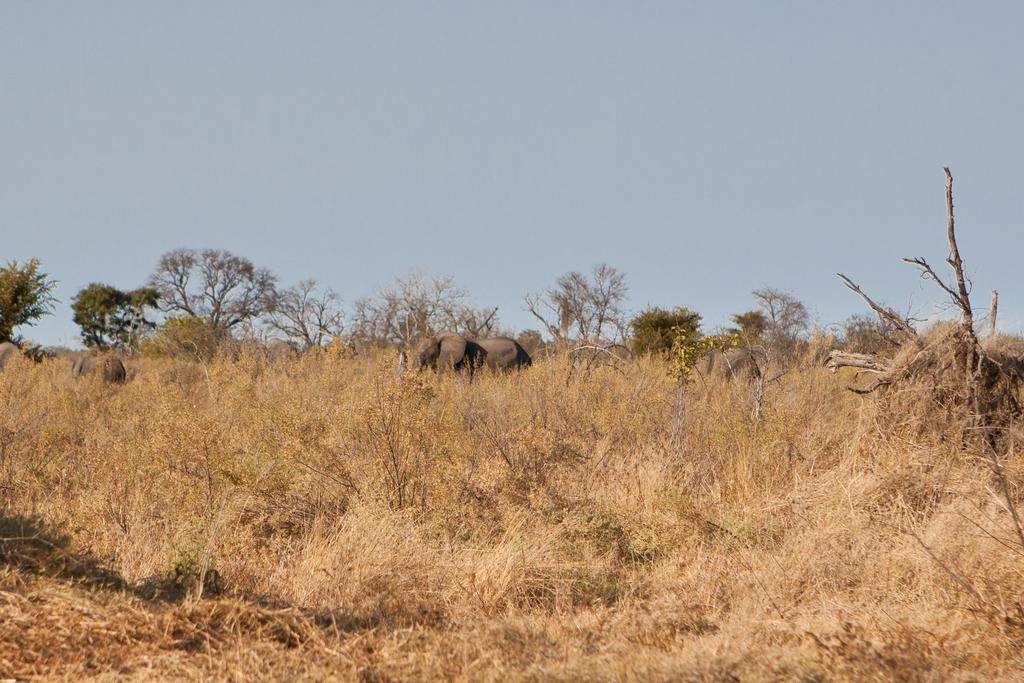What animals can be seen in the image? There are elephants in the image. What type of vegetation is present in the image? There are trees and dried plants in the image. What can be seen in the background of the image? The sky is visible in the background of the image. What type of zinc is being used as bait for the elephants in the image? There is no zinc or bait present in the image; it features elephants and vegetation. Can you see any wires attached to the elephants in the image? There are no wires visible in the image; it only shows elephants, trees, and dried plants. 